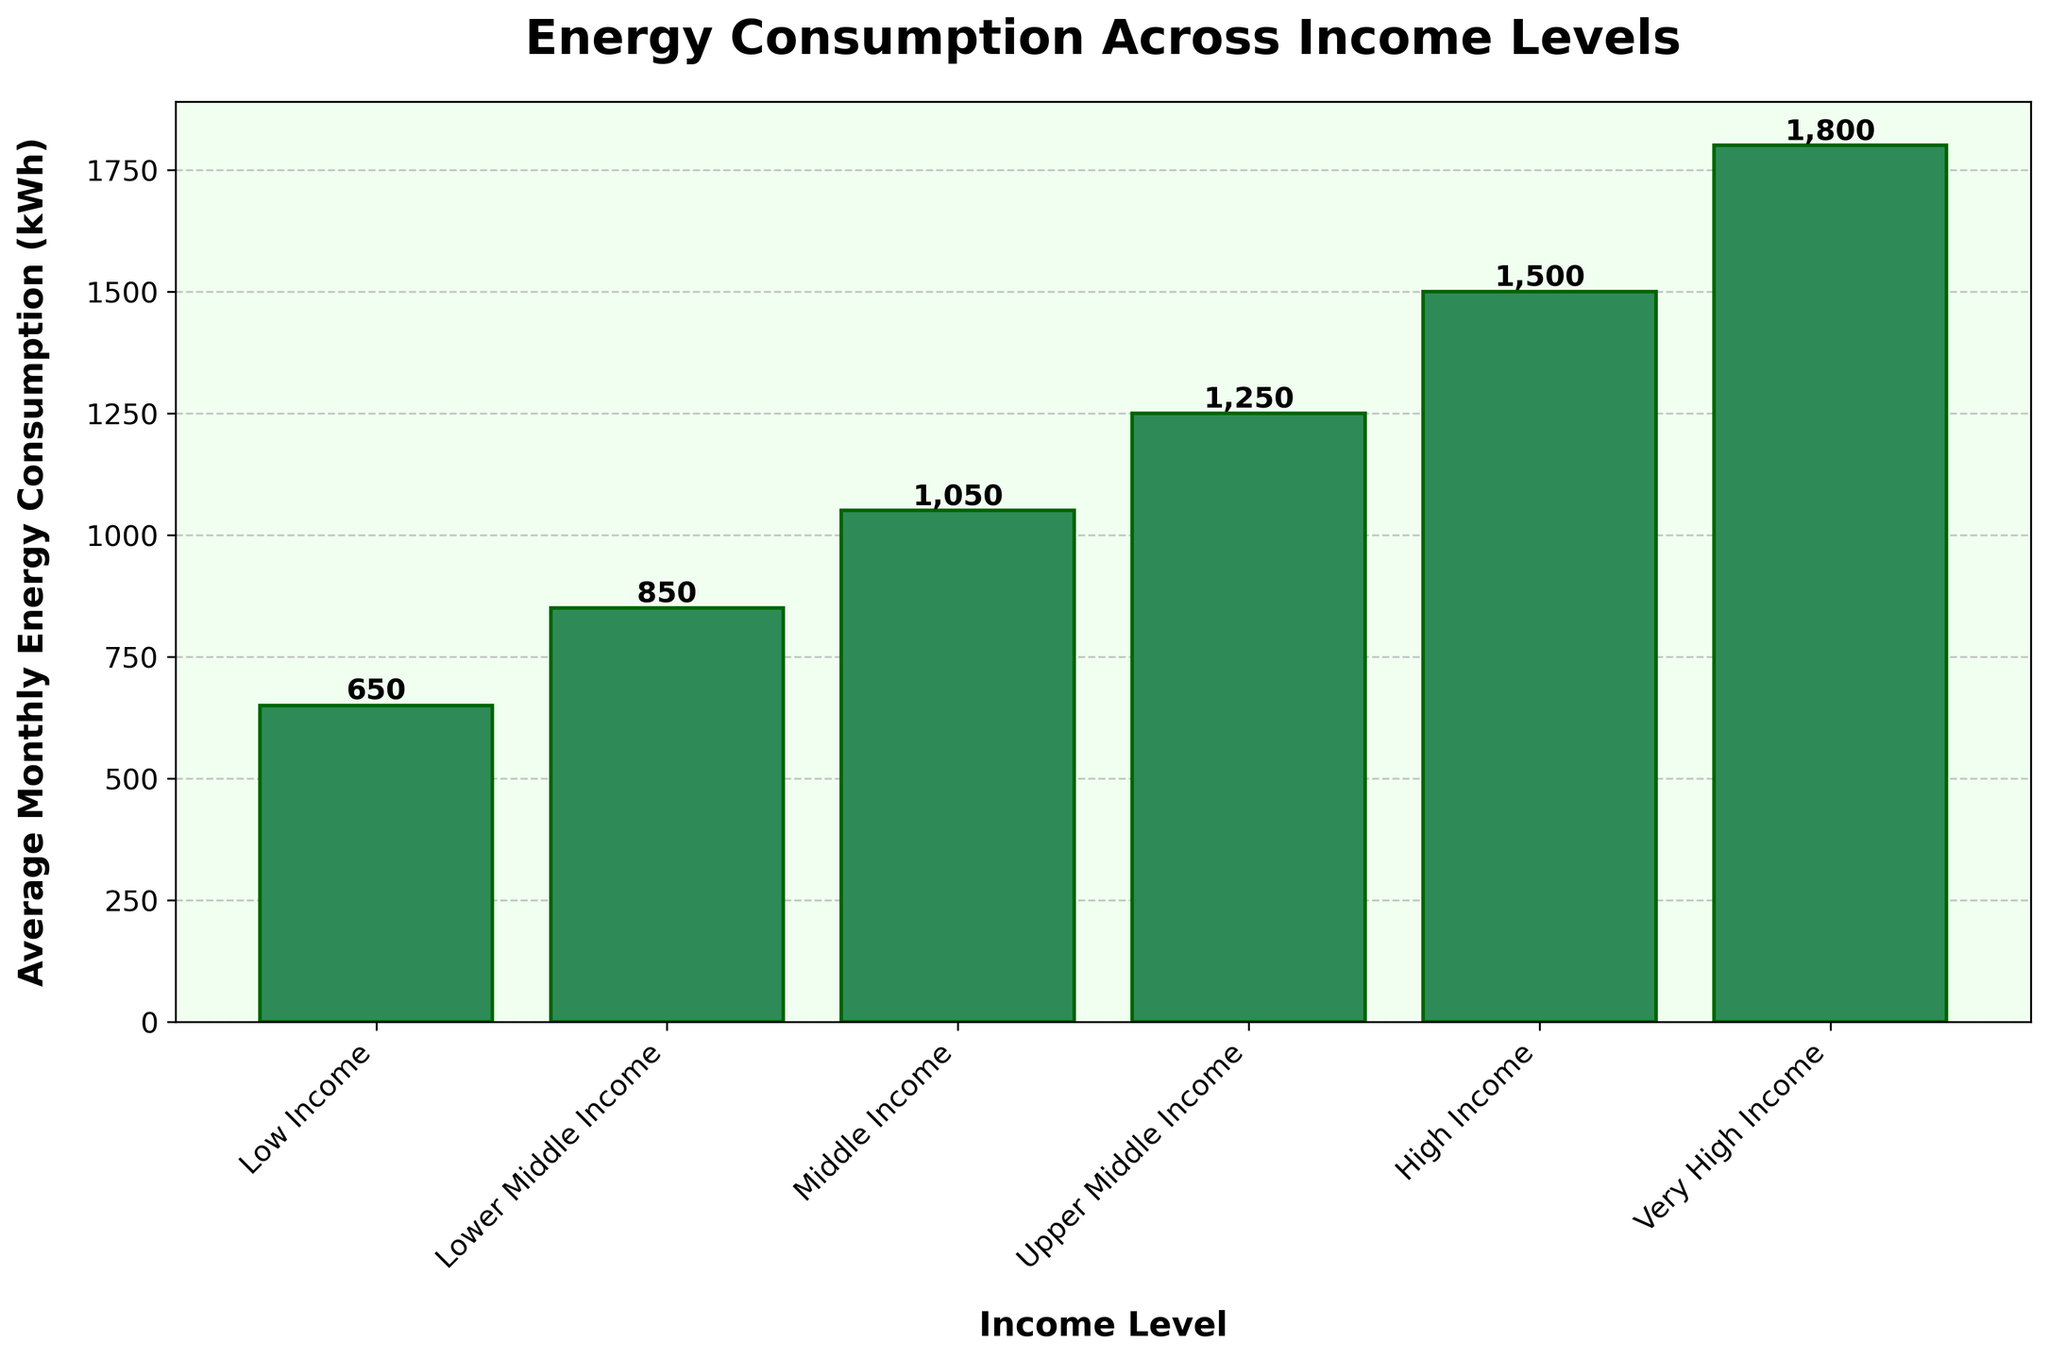What's the average monthly energy consumption for all income levels combined? First, sum the energy consumption values for all income levels: 650 + 850 + 1050 + 1250 + 1500 + 1800 = 7100 kWh. Then, divide by the number of income levels, which is 6. Therefore, the average is 7100 / 6 ≈ 1183.33 kWh.
Answer: 1183.33 kWh Which income level has the highest average monthly energy consumption? The income level with the highest bar in the bar chart represents the highest energy consumption. The highest bar corresponds to "Very High Income" with 1800 kWh.
Answer: Very High Income How much more energy does the high-income level consume compared to the middle-income level? Subtract the average monthly energy consumption of the middle-income level from that of the high-income level: 1500 kWh (High Income) - 1050 kWh (Middle Income) = 450 kWh.
Answer: 450 kWh Which income level has the lowest average monthly energy consumption? The income level with the smallest bar in the bar chart represents the lowest energy consumption. The smallest bar corresponds to "Low Income" with 650 kWh.
Answer: Low Income What is the range of average monthly energy consumption across all income levels? The range is calculated as the difference between the maximum and minimum values. The maximum value is 1800 kWh (Very High Income) and the minimum value is 650 kWh (Low Income). Therefore, the range is 1800 - 650 = 1150 kWh.
Answer: 1150 kWh By how much does the energy consumption increase from the lower-middle income level to the upper-middle income level? Subtract the lower-middle income level's consumption from the upper-middle income level's: 1250 kWh (Upper Middle Income) - 850 kWh (Lower Middle Income) = 400 kWh.
Answer: 400 kWh What is the median value of average monthly energy consumption across the income levels? To find the median, arrange the consumption values in ascending order: 650, 850, 1050, 1250, 1500, 1800. The median is the average of the middle two numbers in this even-sized list: (1050 + 1250) / 2 = 1150 kWh.
Answer: 1150 kWh By what percentage is the energy consumption of the very high-income level greater than the low-income level? First, calculate the difference in consumption: 1800 kWh (Very High Income) - 650 kWh (Low Income) = 1150 kWh. Then, to find the percentage increase, divide the difference by the low income level's consumption and multiply by 100: (1150 / 650) * 100 ≈ 176.92%.
Answer: 176.92% If the energy consumption of upper middle-income increased by 10%, what would the new consumption value be? First, calculate 10% of the upper middle-income consumption: 10% of 1250 kWh = 125 kWh. Then, add this to the original consumption value: 1250 kWh + 125 kWh = 1375 kWh.
Answer: 1375 kWh 